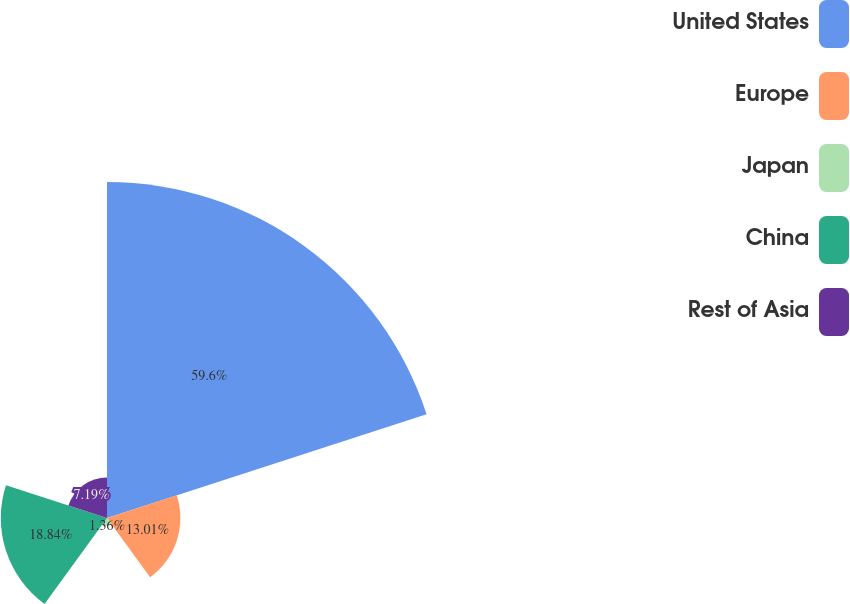<chart> <loc_0><loc_0><loc_500><loc_500><pie_chart><fcel>United States<fcel>Europe<fcel>Japan<fcel>China<fcel>Rest of Asia<nl><fcel>59.6%<fcel>13.01%<fcel>1.36%<fcel>18.84%<fcel>7.19%<nl></chart> 